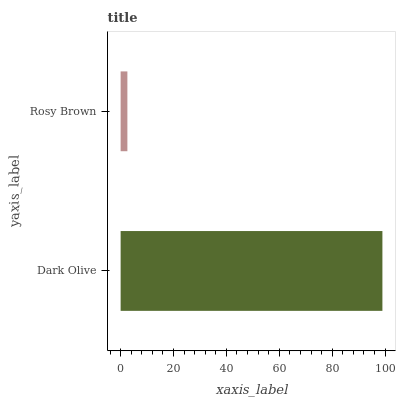Is Rosy Brown the minimum?
Answer yes or no. Yes. Is Dark Olive the maximum?
Answer yes or no. Yes. Is Rosy Brown the maximum?
Answer yes or no. No. Is Dark Olive greater than Rosy Brown?
Answer yes or no. Yes. Is Rosy Brown less than Dark Olive?
Answer yes or no. Yes. Is Rosy Brown greater than Dark Olive?
Answer yes or no. No. Is Dark Olive less than Rosy Brown?
Answer yes or no. No. Is Dark Olive the high median?
Answer yes or no. Yes. Is Rosy Brown the low median?
Answer yes or no. Yes. Is Rosy Brown the high median?
Answer yes or no. No. Is Dark Olive the low median?
Answer yes or no. No. 